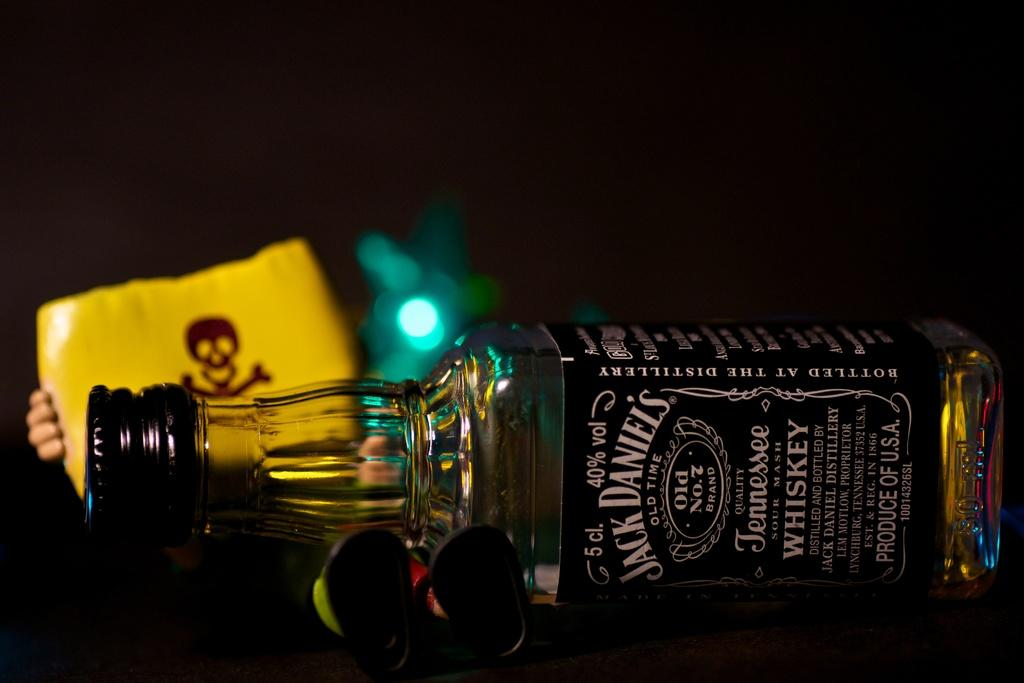What object can be seen in the image that might contain a liquid? There is a bottle in the image that might contain a liquid. What warning is depicted on the board in the image? There is a danger sign on the board in the image. Who is holding the board in the image? A person is holding the board in the image. Can you see the person's chin in the image? There is no mention of the person's chin in the provided facts, so it cannot be determined whether it is visible in the image. 